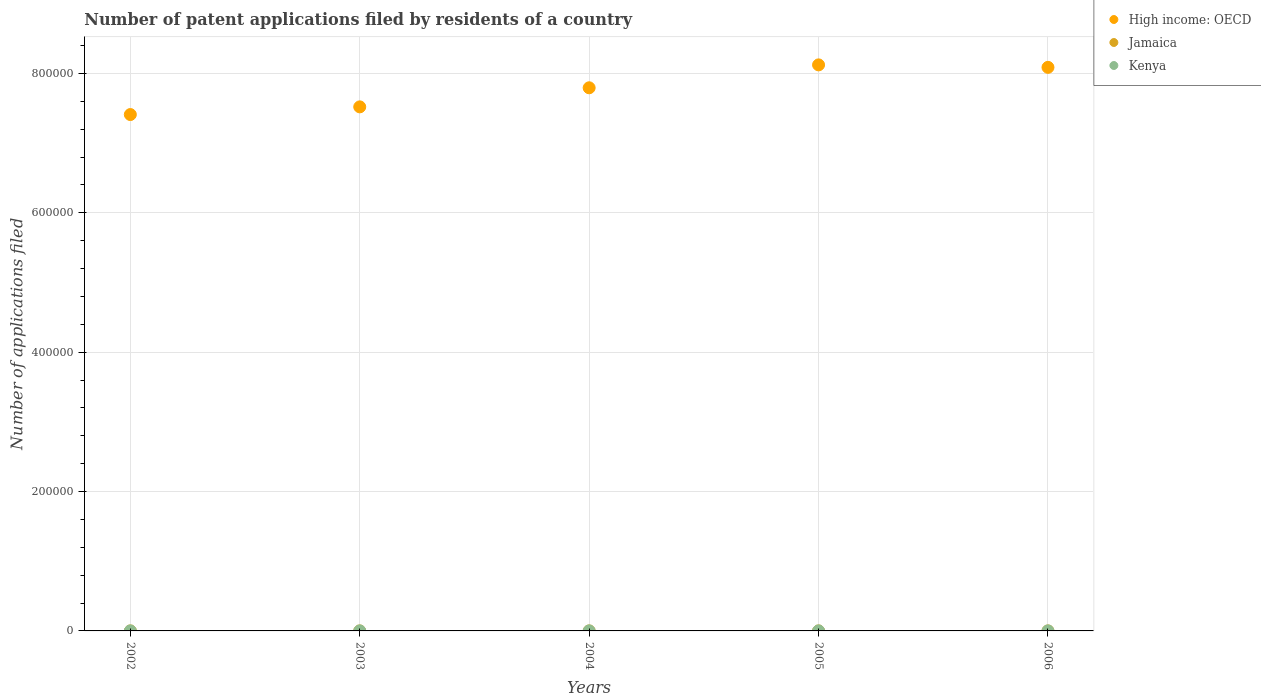Is the number of dotlines equal to the number of legend labels?
Your response must be concise. Yes. What is the number of applications filed in Jamaica in 2005?
Your response must be concise. 10. Across all years, what is the maximum number of applications filed in High income: OECD?
Ensure brevity in your answer.  8.12e+05. In which year was the number of applications filed in Kenya maximum?
Your answer should be compact. 2006. In which year was the number of applications filed in Kenya minimum?
Your answer should be very brief. 2003. What is the total number of applications filed in Jamaica in the graph?
Your response must be concise. 66. What is the difference between the number of applications filed in Jamaica in 2004 and the number of applications filed in Kenya in 2002?
Give a very brief answer. -12. What is the average number of applications filed in Kenya per year?
Give a very brief answer. 30.2. In the year 2006, what is the difference between the number of applications filed in Jamaica and number of applications filed in High income: OECD?
Keep it short and to the point. -8.09e+05. In how many years, is the number of applications filed in Jamaica greater than 240000?
Offer a very short reply. 0. What is the ratio of the number of applications filed in Jamaica in 2002 to that in 2004?
Provide a succinct answer. 1.36. Is the number of applications filed in Jamaica in 2003 less than that in 2005?
Provide a succinct answer. Yes. Is the difference between the number of applications filed in Jamaica in 2004 and 2006 greater than the difference between the number of applications filed in High income: OECD in 2004 and 2006?
Provide a succinct answer. Yes. What is the difference between the highest and the second highest number of applications filed in Kenya?
Offer a very short reply. 7. Does the number of applications filed in Jamaica monotonically increase over the years?
Your answer should be compact. No. Is the number of applications filed in High income: OECD strictly less than the number of applications filed in Jamaica over the years?
Your answer should be very brief. No. Are the values on the major ticks of Y-axis written in scientific E-notation?
Ensure brevity in your answer.  No. Does the graph contain grids?
Offer a very short reply. Yes. What is the title of the graph?
Your answer should be very brief. Number of patent applications filed by residents of a country. Does "Estonia" appear as one of the legend labels in the graph?
Your response must be concise. No. What is the label or title of the Y-axis?
Make the answer very short. Number of applications filed. What is the Number of applications filed of High income: OECD in 2002?
Your answer should be very brief. 7.41e+05. What is the Number of applications filed in High income: OECD in 2003?
Offer a very short reply. 7.52e+05. What is the Number of applications filed in High income: OECD in 2004?
Provide a succinct answer. 7.79e+05. What is the Number of applications filed of Jamaica in 2004?
Provide a short and direct response. 11. What is the Number of applications filed of Kenya in 2004?
Provide a short and direct response. 31. What is the Number of applications filed of High income: OECD in 2005?
Provide a succinct answer. 8.12e+05. What is the Number of applications filed in Jamaica in 2005?
Offer a terse response. 10. What is the Number of applications filed in Kenya in 2005?
Keep it short and to the point. 34. What is the Number of applications filed in High income: OECD in 2006?
Make the answer very short. 8.09e+05. What is the Number of applications filed in Jamaica in 2006?
Your response must be concise. 21. Across all years, what is the maximum Number of applications filed in High income: OECD?
Keep it short and to the point. 8.12e+05. Across all years, what is the maximum Number of applications filed of Jamaica?
Offer a terse response. 21. Across all years, what is the maximum Number of applications filed in Kenya?
Provide a short and direct response. 41. Across all years, what is the minimum Number of applications filed in High income: OECD?
Ensure brevity in your answer.  7.41e+05. Across all years, what is the minimum Number of applications filed in Jamaica?
Provide a short and direct response. 9. What is the total Number of applications filed of High income: OECD in the graph?
Your answer should be compact. 3.89e+06. What is the total Number of applications filed of Kenya in the graph?
Your answer should be very brief. 151. What is the difference between the Number of applications filed in High income: OECD in 2002 and that in 2003?
Ensure brevity in your answer.  -1.10e+04. What is the difference between the Number of applications filed of Jamaica in 2002 and that in 2003?
Provide a succinct answer. 6. What is the difference between the Number of applications filed of High income: OECD in 2002 and that in 2004?
Your answer should be compact. -3.84e+04. What is the difference between the Number of applications filed of Jamaica in 2002 and that in 2004?
Offer a terse response. 4. What is the difference between the Number of applications filed in High income: OECD in 2002 and that in 2005?
Offer a terse response. -7.13e+04. What is the difference between the Number of applications filed in Jamaica in 2002 and that in 2005?
Offer a terse response. 5. What is the difference between the Number of applications filed of Kenya in 2002 and that in 2005?
Provide a short and direct response. -11. What is the difference between the Number of applications filed in High income: OECD in 2002 and that in 2006?
Offer a terse response. -6.77e+04. What is the difference between the Number of applications filed in Kenya in 2002 and that in 2006?
Keep it short and to the point. -18. What is the difference between the Number of applications filed of High income: OECD in 2003 and that in 2004?
Your answer should be very brief. -2.74e+04. What is the difference between the Number of applications filed in High income: OECD in 2003 and that in 2005?
Ensure brevity in your answer.  -6.03e+04. What is the difference between the Number of applications filed of Jamaica in 2003 and that in 2005?
Provide a short and direct response. -1. What is the difference between the Number of applications filed of Kenya in 2003 and that in 2005?
Provide a succinct answer. -12. What is the difference between the Number of applications filed in High income: OECD in 2003 and that in 2006?
Offer a very short reply. -5.67e+04. What is the difference between the Number of applications filed of Jamaica in 2003 and that in 2006?
Make the answer very short. -12. What is the difference between the Number of applications filed of Kenya in 2003 and that in 2006?
Give a very brief answer. -19. What is the difference between the Number of applications filed of High income: OECD in 2004 and that in 2005?
Provide a short and direct response. -3.29e+04. What is the difference between the Number of applications filed of Jamaica in 2004 and that in 2005?
Your answer should be compact. 1. What is the difference between the Number of applications filed in Kenya in 2004 and that in 2005?
Give a very brief answer. -3. What is the difference between the Number of applications filed of High income: OECD in 2004 and that in 2006?
Provide a short and direct response. -2.93e+04. What is the difference between the Number of applications filed of Jamaica in 2004 and that in 2006?
Provide a short and direct response. -10. What is the difference between the Number of applications filed of High income: OECD in 2005 and that in 2006?
Your answer should be very brief. 3553. What is the difference between the Number of applications filed of High income: OECD in 2002 and the Number of applications filed of Jamaica in 2003?
Offer a very short reply. 7.41e+05. What is the difference between the Number of applications filed in High income: OECD in 2002 and the Number of applications filed in Kenya in 2003?
Offer a very short reply. 7.41e+05. What is the difference between the Number of applications filed of High income: OECD in 2002 and the Number of applications filed of Jamaica in 2004?
Ensure brevity in your answer.  7.41e+05. What is the difference between the Number of applications filed of High income: OECD in 2002 and the Number of applications filed of Kenya in 2004?
Keep it short and to the point. 7.41e+05. What is the difference between the Number of applications filed in High income: OECD in 2002 and the Number of applications filed in Jamaica in 2005?
Make the answer very short. 7.41e+05. What is the difference between the Number of applications filed of High income: OECD in 2002 and the Number of applications filed of Kenya in 2005?
Offer a very short reply. 7.41e+05. What is the difference between the Number of applications filed of Jamaica in 2002 and the Number of applications filed of Kenya in 2005?
Offer a very short reply. -19. What is the difference between the Number of applications filed in High income: OECD in 2002 and the Number of applications filed in Jamaica in 2006?
Provide a short and direct response. 7.41e+05. What is the difference between the Number of applications filed of High income: OECD in 2002 and the Number of applications filed of Kenya in 2006?
Offer a very short reply. 7.41e+05. What is the difference between the Number of applications filed in Jamaica in 2002 and the Number of applications filed in Kenya in 2006?
Keep it short and to the point. -26. What is the difference between the Number of applications filed in High income: OECD in 2003 and the Number of applications filed in Jamaica in 2004?
Provide a short and direct response. 7.52e+05. What is the difference between the Number of applications filed in High income: OECD in 2003 and the Number of applications filed in Kenya in 2004?
Offer a very short reply. 7.52e+05. What is the difference between the Number of applications filed in Jamaica in 2003 and the Number of applications filed in Kenya in 2004?
Your answer should be compact. -22. What is the difference between the Number of applications filed in High income: OECD in 2003 and the Number of applications filed in Jamaica in 2005?
Offer a terse response. 7.52e+05. What is the difference between the Number of applications filed of High income: OECD in 2003 and the Number of applications filed of Kenya in 2005?
Offer a very short reply. 7.52e+05. What is the difference between the Number of applications filed of High income: OECD in 2003 and the Number of applications filed of Jamaica in 2006?
Offer a very short reply. 7.52e+05. What is the difference between the Number of applications filed in High income: OECD in 2003 and the Number of applications filed in Kenya in 2006?
Your answer should be compact. 7.52e+05. What is the difference between the Number of applications filed in Jamaica in 2003 and the Number of applications filed in Kenya in 2006?
Give a very brief answer. -32. What is the difference between the Number of applications filed in High income: OECD in 2004 and the Number of applications filed in Jamaica in 2005?
Your answer should be very brief. 7.79e+05. What is the difference between the Number of applications filed in High income: OECD in 2004 and the Number of applications filed in Kenya in 2005?
Provide a short and direct response. 7.79e+05. What is the difference between the Number of applications filed in Jamaica in 2004 and the Number of applications filed in Kenya in 2005?
Provide a short and direct response. -23. What is the difference between the Number of applications filed of High income: OECD in 2004 and the Number of applications filed of Jamaica in 2006?
Make the answer very short. 7.79e+05. What is the difference between the Number of applications filed in High income: OECD in 2004 and the Number of applications filed in Kenya in 2006?
Ensure brevity in your answer.  7.79e+05. What is the difference between the Number of applications filed in Jamaica in 2004 and the Number of applications filed in Kenya in 2006?
Your response must be concise. -30. What is the difference between the Number of applications filed in High income: OECD in 2005 and the Number of applications filed in Jamaica in 2006?
Offer a very short reply. 8.12e+05. What is the difference between the Number of applications filed in High income: OECD in 2005 and the Number of applications filed in Kenya in 2006?
Ensure brevity in your answer.  8.12e+05. What is the difference between the Number of applications filed in Jamaica in 2005 and the Number of applications filed in Kenya in 2006?
Keep it short and to the point. -31. What is the average Number of applications filed of High income: OECD per year?
Provide a short and direct response. 7.79e+05. What is the average Number of applications filed in Jamaica per year?
Provide a short and direct response. 13.2. What is the average Number of applications filed of Kenya per year?
Your answer should be compact. 30.2. In the year 2002, what is the difference between the Number of applications filed of High income: OECD and Number of applications filed of Jamaica?
Your answer should be very brief. 7.41e+05. In the year 2002, what is the difference between the Number of applications filed of High income: OECD and Number of applications filed of Kenya?
Offer a terse response. 7.41e+05. In the year 2003, what is the difference between the Number of applications filed of High income: OECD and Number of applications filed of Jamaica?
Your answer should be very brief. 7.52e+05. In the year 2003, what is the difference between the Number of applications filed of High income: OECD and Number of applications filed of Kenya?
Give a very brief answer. 7.52e+05. In the year 2003, what is the difference between the Number of applications filed in Jamaica and Number of applications filed in Kenya?
Offer a terse response. -13. In the year 2004, what is the difference between the Number of applications filed of High income: OECD and Number of applications filed of Jamaica?
Your answer should be compact. 7.79e+05. In the year 2004, what is the difference between the Number of applications filed of High income: OECD and Number of applications filed of Kenya?
Your response must be concise. 7.79e+05. In the year 2004, what is the difference between the Number of applications filed of Jamaica and Number of applications filed of Kenya?
Ensure brevity in your answer.  -20. In the year 2005, what is the difference between the Number of applications filed of High income: OECD and Number of applications filed of Jamaica?
Your answer should be very brief. 8.12e+05. In the year 2005, what is the difference between the Number of applications filed of High income: OECD and Number of applications filed of Kenya?
Provide a short and direct response. 8.12e+05. In the year 2005, what is the difference between the Number of applications filed of Jamaica and Number of applications filed of Kenya?
Keep it short and to the point. -24. In the year 2006, what is the difference between the Number of applications filed of High income: OECD and Number of applications filed of Jamaica?
Provide a succinct answer. 8.09e+05. In the year 2006, what is the difference between the Number of applications filed in High income: OECD and Number of applications filed in Kenya?
Offer a terse response. 8.09e+05. What is the ratio of the Number of applications filed in High income: OECD in 2002 to that in 2003?
Keep it short and to the point. 0.99. What is the ratio of the Number of applications filed of Kenya in 2002 to that in 2003?
Your response must be concise. 1.05. What is the ratio of the Number of applications filed of High income: OECD in 2002 to that in 2004?
Offer a very short reply. 0.95. What is the ratio of the Number of applications filed in Jamaica in 2002 to that in 2004?
Provide a short and direct response. 1.36. What is the ratio of the Number of applications filed in Kenya in 2002 to that in 2004?
Ensure brevity in your answer.  0.74. What is the ratio of the Number of applications filed of High income: OECD in 2002 to that in 2005?
Your answer should be very brief. 0.91. What is the ratio of the Number of applications filed in Kenya in 2002 to that in 2005?
Provide a succinct answer. 0.68. What is the ratio of the Number of applications filed of High income: OECD in 2002 to that in 2006?
Give a very brief answer. 0.92. What is the ratio of the Number of applications filed of Kenya in 2002 to that in 2006?
Your answer should be very brief. 0.56. What is the ratio of the Number of applications filed in High income: OECD in 2003 to that in 2004?
Your response must be concise. 0.96. What is the ratio of the Number of applications filed in Jamaica in 2003 to that in 2004?
Offer a very short reply. 0.82. What is the ratio of the Number of applications filed in Kenya in 2003 to that in 2004?
Ensure brevity in your answer.  0.71. What is the ratio of the Number of applications filed in High income: OECD in 2003 to that in 2005?
Ensure brevity in your answer.  0.93. What is the ratio of the Number of applications filed in Kenya in 2003 to that in 2005?
Your answer should be compact. 0.65. What is the ratio of the Number of applications filed in High income: OECD in 2003 to that in 2006?
Offer a terse response. 0.93. What is the ratio of the Number of applications filed of Jamaica in 2003 to that in 2006?
Provide a short and direct response. 0.43. What is the ratio of the Number of applications filed of Kenya in 2003 to that in 2006?
Offer a very short reply. 0.54. What is the ratio of the Number of applications filed in High income: OECD in 2004 to that in 2005?
Keep it short and to the point. 0.96. What is the ratio of the Number of applications filed in Kenya in 2004 to that in 2005?
Offer a very short reply. 0.91. What is the ratio of the Number of applications filed of High income: OECD in 2004 to that in 2006?
Provide a short and direct response. 0.96. What is the ratio of the Number of applications filed of Jamaica in 2004 to that in 2006?
Offer a terse response. 0.52. What is the ratio of the Number of applications filed in Kenya in 2004 to that in 2006?
Offer a very short reply. 0.76. What is the ratio of the Number of applications filed in Jamaica in 2005 to that in 2006?
Offer a terse response. 0.48. What is the ratio of the Number of applications filed of Kenya in 2005 to that in 2006?
Your response must be concise. 0.83. What is the difference between the highest and the second highest Number of applications filed in High income: OECD?
Your answer should be very brief. 3553. What is the difference between the highest and the second highest Number of applications filed in Jamaica?
Give a very brief answer. 6. What is the difference between the highest and the second highest Number of applications filed in Kenya?
Make the answer very short. 7. What is the difference between the highest and the lowest Number of applications filed in High income: OECD?
Your answer should be compact. 7.13e+04. What is the difference between the highest and the lowest Number of applications filed of Jamaica?
Ensure brevity in your answer.  12. What is the difference between the highest and the lowest Number of applications filed of Kenya?
Make the answer very short. 19. 